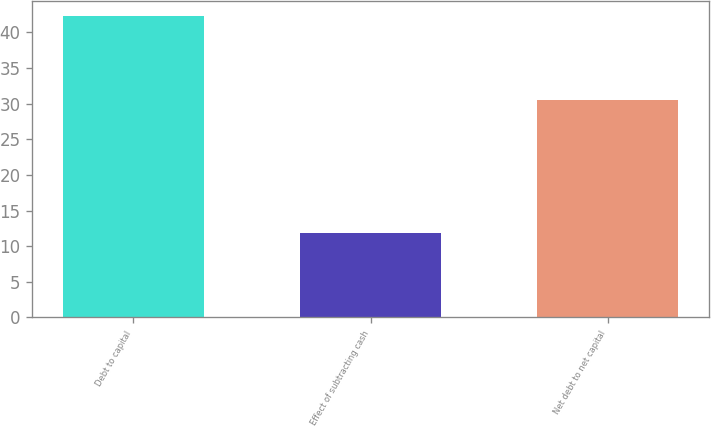Convert chart to OTSL. <chart><loc_0><loc_0><loc_500><loc_500><bar_chart><fcel>Debt to capital<fcel>Effect of subtracting cash<fcel>Net debt to net capital<nl><fcel>42.3<fcel>11.8<fcel>30.5<nl></chart> 